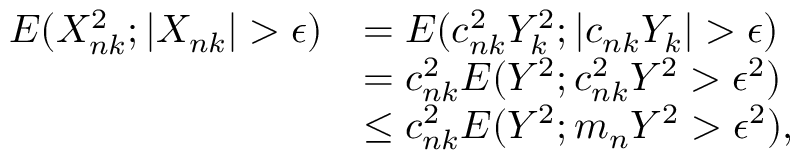Convert formula to latex. <formula><loc_0><loc_0><loc_500><loc_500>\begin{array} { r l } { E ( X _ { n k } ^ { 2 } ; | X _ { n k } | > \epsilon ) } & { = E ( c _ { n k } ^ { 2 } Y _ { k } ^ { 2 } ; | c _ { n k } Y _ { k } | > \epsilon ) } \\ & { = c _ { n k } ^ { 2 } E ( Y ^ { 2 } ; c _ { n k } ^ { 2 } Y ^ { 2 } > \epsilon ^ { 2 } ) } \\ & { \leq c _ { n k } ^ { 2 } E ( Y ^ { 2 } ; m _ { n } Y ^ { 2 } > \epsilon ^ { 2 } ) , } \end{array}</formula> 